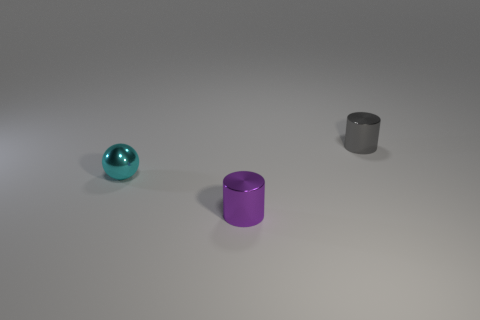What are the material properties of the objects in this image? The objects in the image display diverse material properties. The cyan object has a reflective, glossy finish, indicative of a metallic or polished surface. The purple cylinder appears to have a diffuse, matte texture, suggesting it might be made of plastic or painted metal. The gray cylinder is similar in texture to the purple one, although its color casts an impression of being made of metal, perhaps steel. 